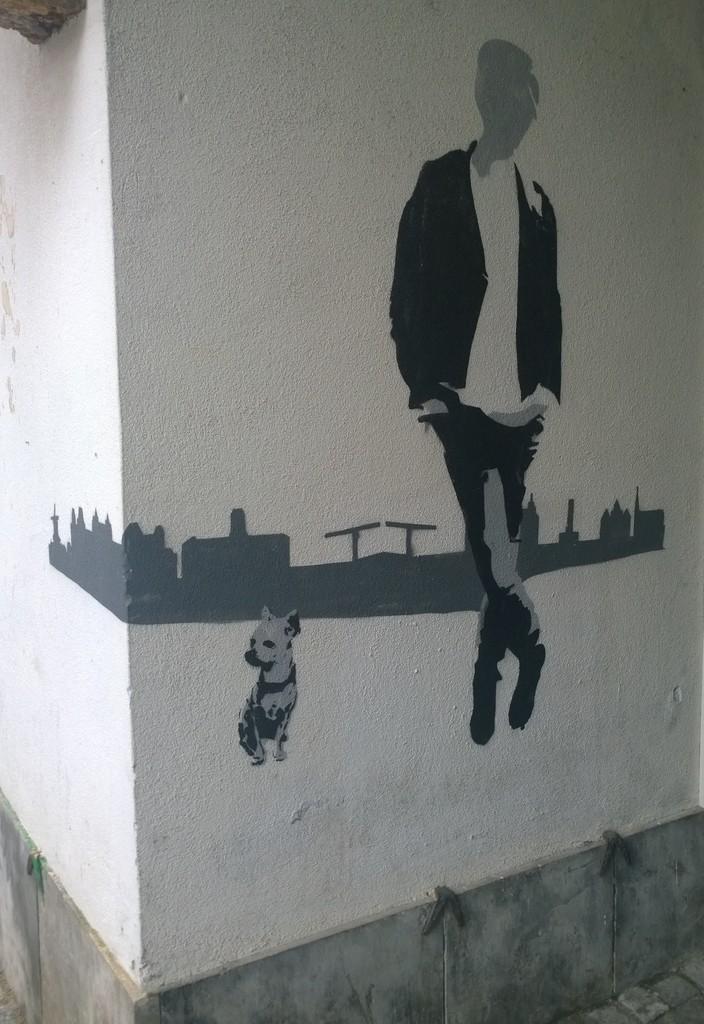In one or two sentences, can you explain what this image depicts? In this image in front there is a painting on the wall. 